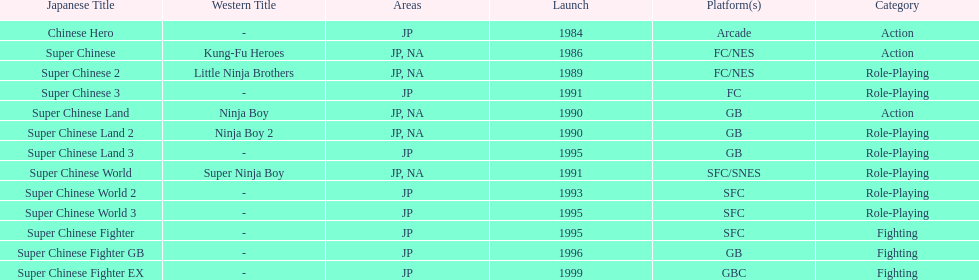Number of super chinese world games released 3. 